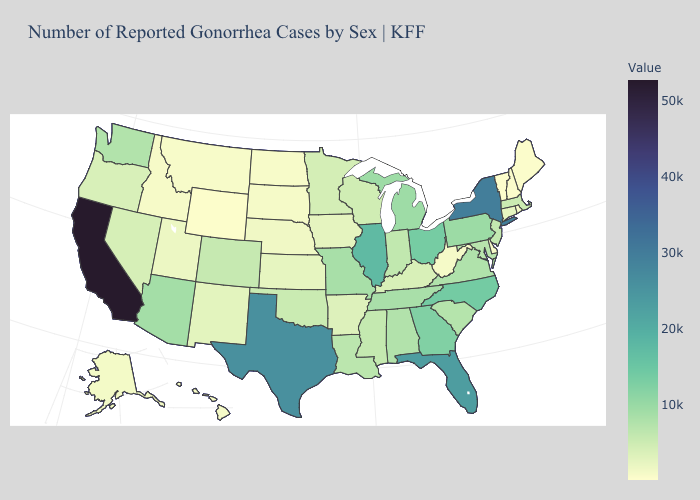Which states have the highest value in the USA?
Quick response, please. California. Is the legend a continuous bar?
Give a very brief answer. Yes. Does Missouri have a lower value than Wyoming?
Write a very short answer. No. Among the states that border South Dakota , does Wyoming have the lowest value?
Write a very short answer. Yes. 